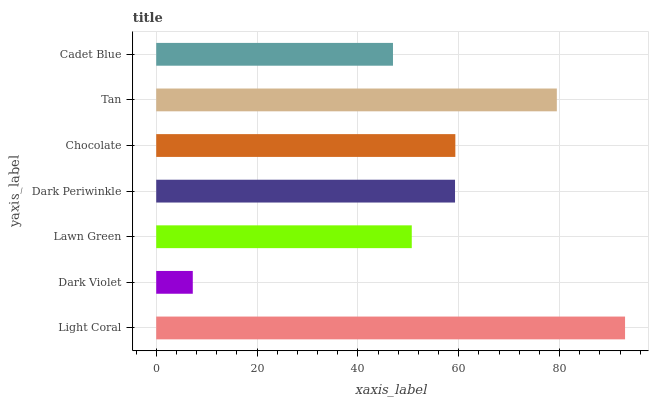Is Dark Violet the minimum?
Answer yes or no. Yes. Is Light Coral the maximum?
Answer yes or no. Yes. Is Lawn Green the minimum?
Answer yes or no. No. Is Lawn Green the maximum?
Answer yes or no. No. Is Lawn Green greater than Dark Violet?
Answer yes or no. Yes. Is Dark Violet less than Lawn Green?
Answer yes or no. Yes. Is Dark Violet greater than Lawn Green?
Answer yes or no. No. Is Lawn Green less than Dark Violet?
Answer yes or no. No. Is Dark Periwinkle the high median?
Answer yes or no. Yes. Is Dark Periwinkle the low median?
Answer yes or no. Yes. Is Tan the high median?
Answer yes or no. No. Is Chocolate the low median?
Answer yes or no. No. 